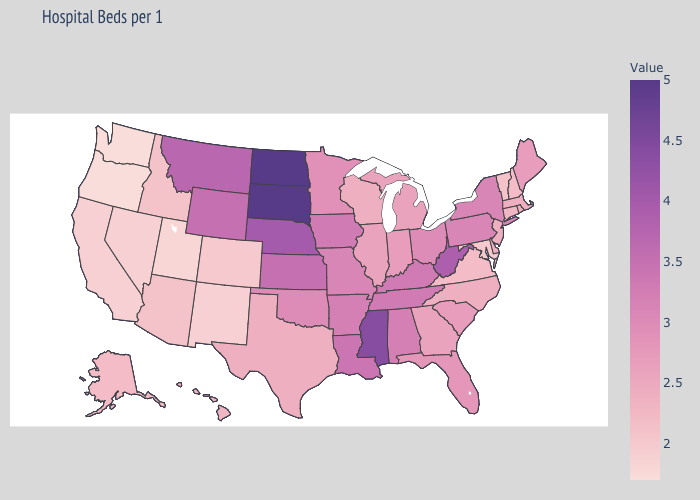Does Kansas have a higher value than New York?
Be succinct. Yes. Which states hav the highest value in the Northeast?
Concise answer only. New York, Pennsylvania. Among the states that border Connecticut , which have the lowest value?
Keep it brief. Massachusetts, Rhode Island. Does the map have missing data?
Quick response, please. No. Among the states that border Georgia , does Tennessee have the highest value?
Keep it brief. Yes. 